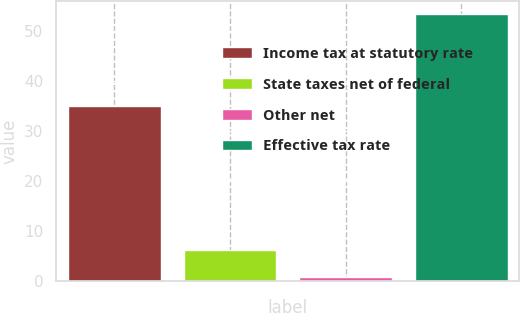<chart> <loc_0><loc_0><loc_500><loc_500><bar_chart><fcel>Income tax at statutory rate<fcel>State taxes net of federal<fcel>Other net<fcel>Effective tax rate<nl><fcel>35<fcel>6.05<fcel>0.8<fcel>53.3<nl></chart> 